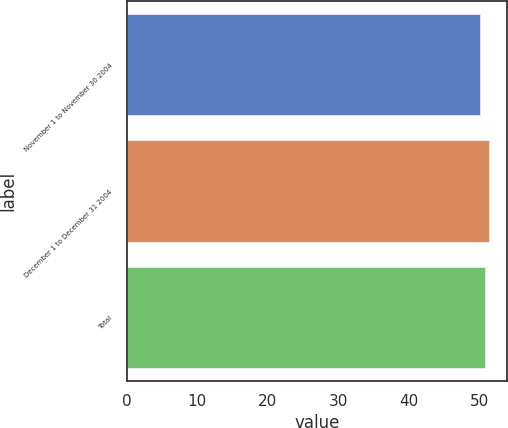Convert chart. <chart><loc_0><loc_0><loc_500><loc_500><bar_chart><fcel>November 1 to November 30 2004<fcel>December 1 to December 31 2004<fcel>Total<nl><fcel>50.02<fcel>51.32<fcel>50.83<nl></chart> 